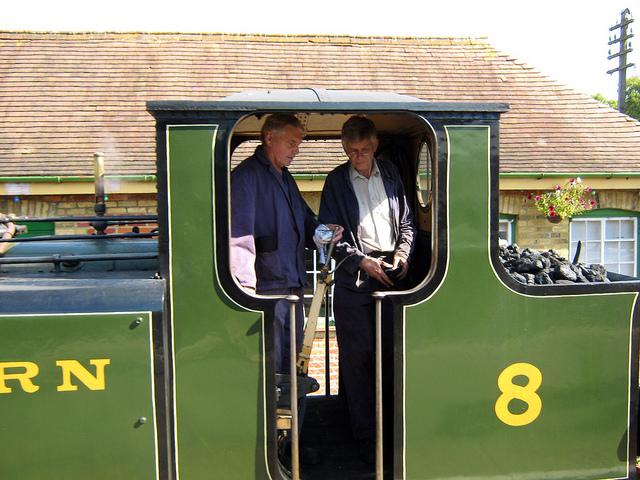What is the number painted on the bus?
Concise answer only. 8. Are the people sitting?
Concise answer only. No. Is this a real train?
Write a very short answer. No. 